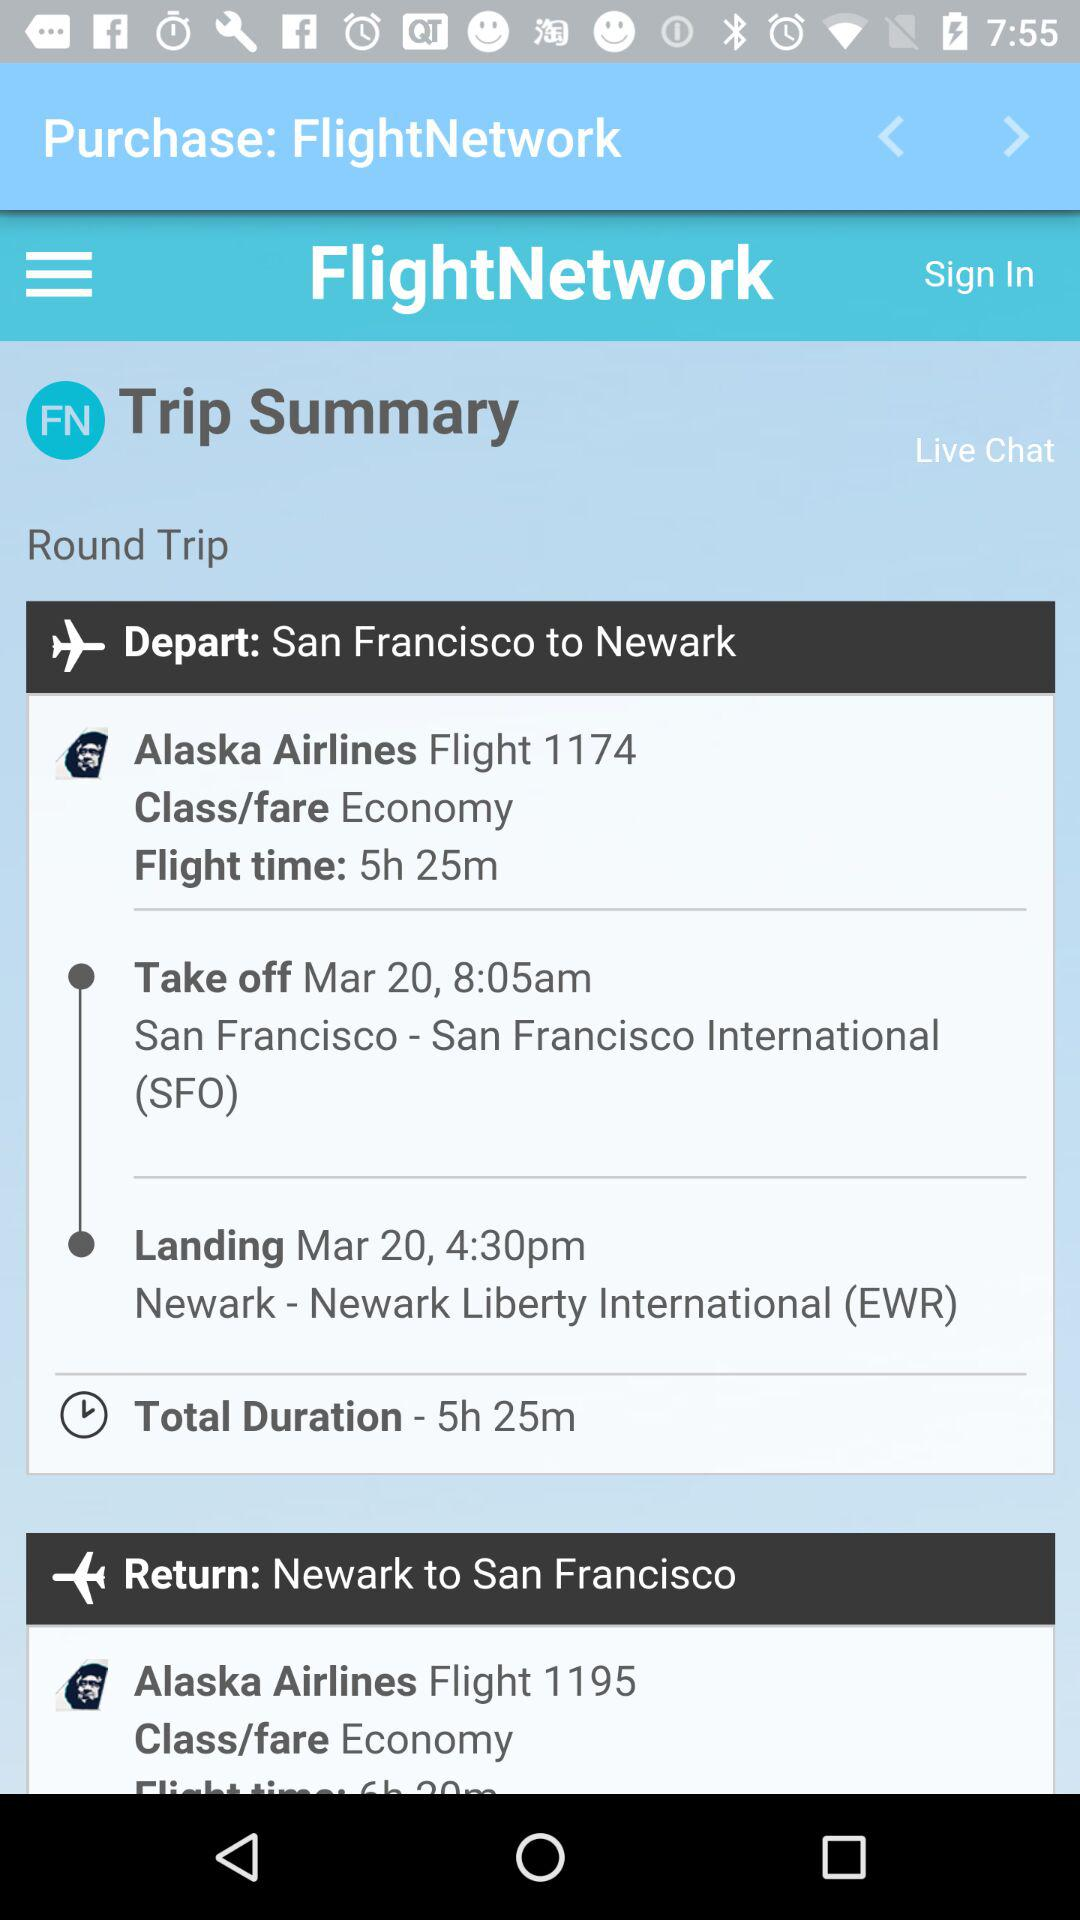What is the flight time from San Francisco to Newark? The flight time from San Francisco to Newark is 5 hours 25 minutes. 